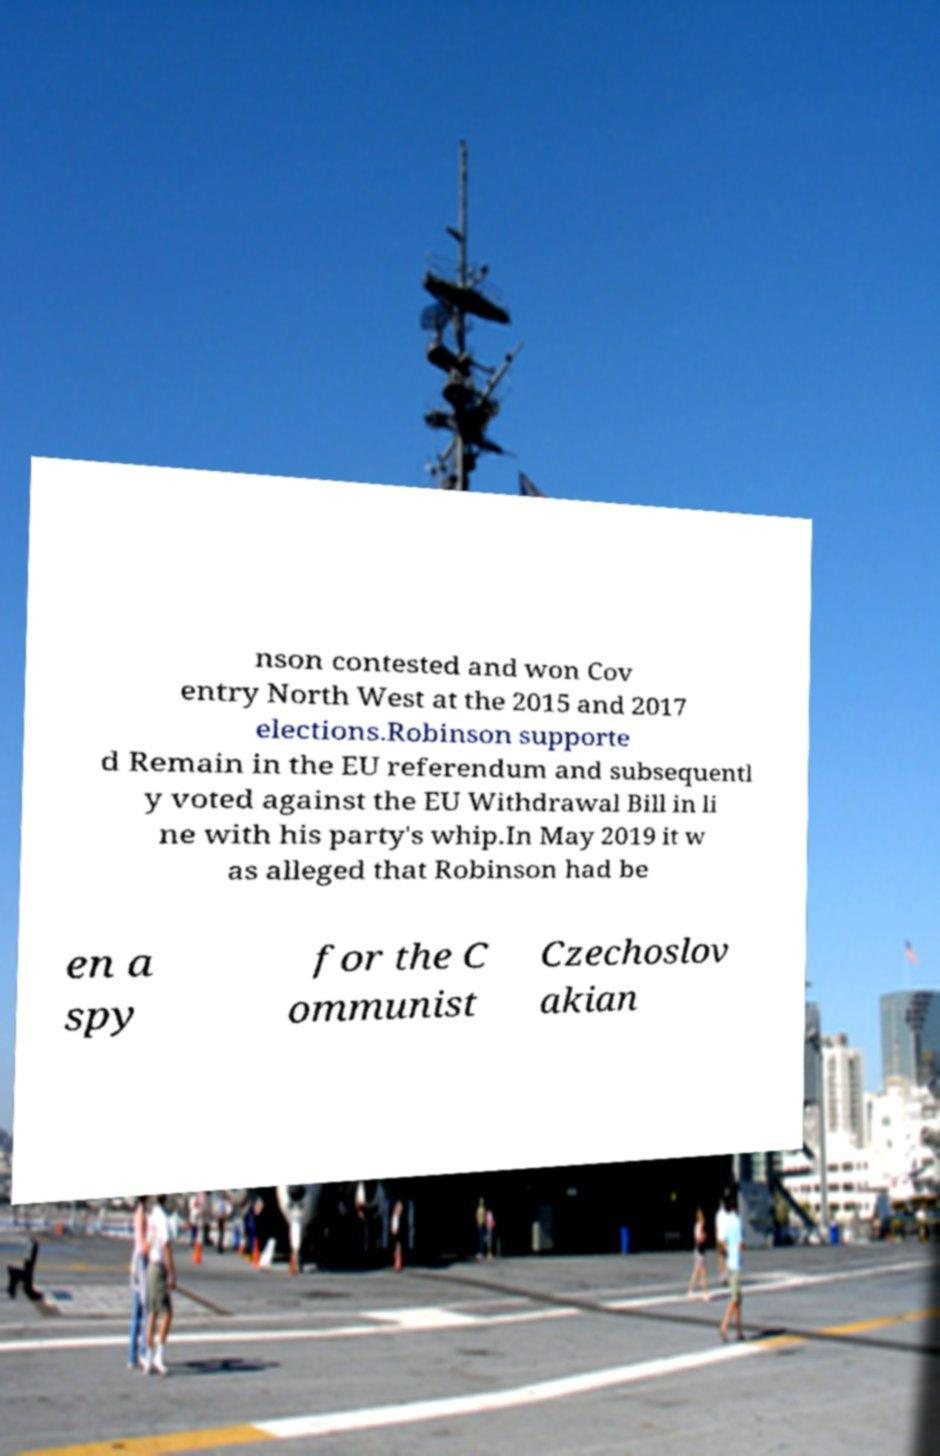Could you extract and type out the text from this image? nson contested and won Cov entry North West at the 2015 and 2017 elections.Robinson supporte d Remain in the EU referendum and subsequentl y voted against the EU Withdrawal Bill in li ne with his party's whip.In May 2019 it w as alleged that Robinson had be en a spy for the C ommunist Czechoslov akian 